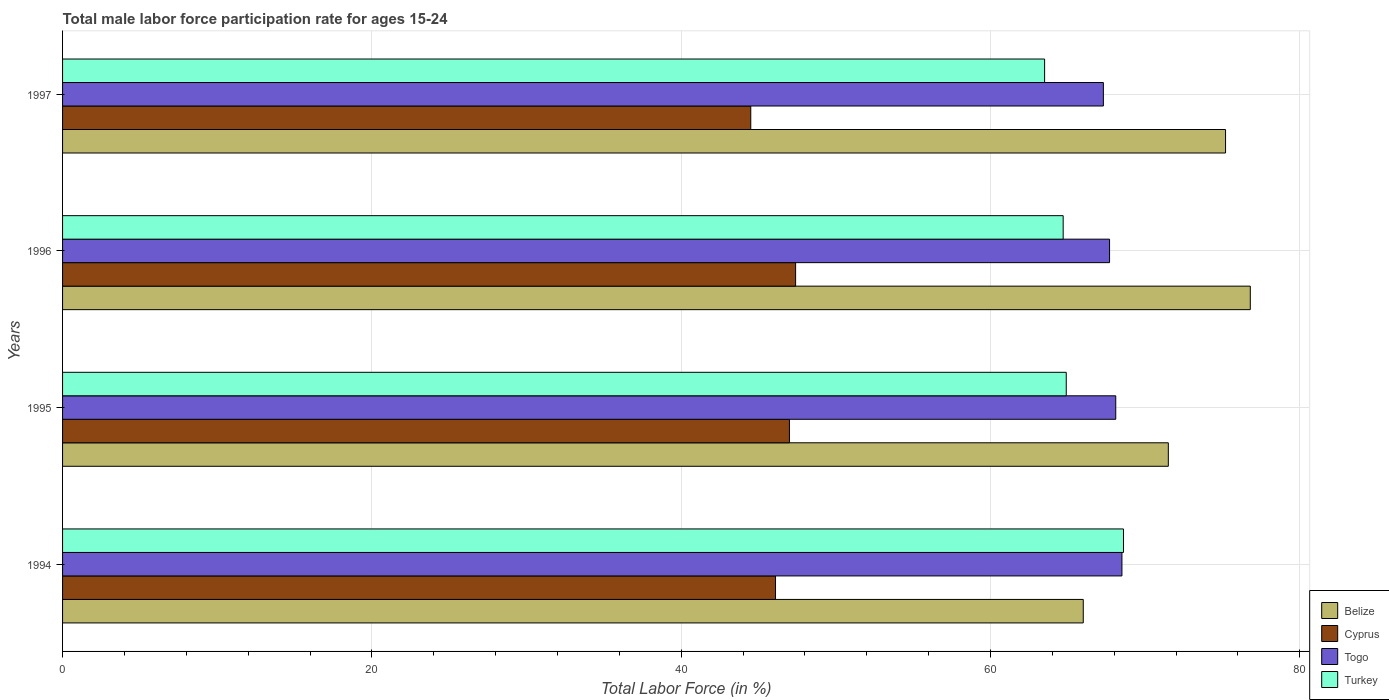How many different coloured bars are there?
Your answer should be compact. 4. How many groups of bars are there?
Keep it short and to the point. 4. How many bars are there on the 3rd tick from the top?
Ensure brevity in your answer.  4. How many bars are there on the 3rd tick from the bottom?
Give a very brief answer. 4. What is the label of the 2nd group of bars from the top?
Ensure brevity in your answer.  1996. In how many cases, is the number of bars for a given year not equal to the number of legend labels?
Make the answer very short. 0. What is the male labor force participation rate in Cyprus in 1997?
Provide a succinct answer. 44.5. Across all years, what is the maximum male labor force participation rate in Togo?
Give a very brief answer. 68.5. In which year was the male labor force participation rate in Cyprus minimum?
Ensure brevity in your answer.  1997. What is the total male labor force participation rate in Cyprus in the graph?
Provide a short and direct response. 185. What is the average male labor force participation rate in Togo per year?
Keep it short and to the point. 67.9. In the year 1996, what is the difference between the male labor force participation rate in Turkey and male labor force participation rate in Togo?
Make the answer very short. -3. What is the ratio of the male labor force participation rate in Turkey in 1994 to that in 1995?
Your answer should be very brief. 1.06. What is the difference between the highest and the second highest male labor force participation rate in Togo?
Provide a succinct answer. 0.4. What is the difference between the highest and the lowest male labor force participation rate in Turkey?
Your response must be concise. 5.1. In how many years, is the male labor force participation rate in Belize greater than the average male labor force participation rate in Belize taken over all years?
Ensure brevity in your answer.  2. Is the sum of the male labor force participation rate in Togo in 1994 and 1996 greater than the maximum male labor force participation rate in Turkey across all years?
Your answer should be very brief. Yes. What does the 2nd bar from the top in 1996 represents?
Keep it short and to the point. Togo. How many bars are there?
Offer a terse response. 16. What is the difference between two consecutive major ticks on the X-axis?
Provide a succinct answer. 20. Does the graph contain any zero values?
Give a very brief answer. No. Does the graph contain grids?
Your response must be concise. Yes. Where does the legend appear in the graph?
Your answer should be very brief. Bottom right. How are the legend labels stacked?
Offer a very short reply. Vertical. What is the title of the graph?
Your answer should be compact. Total male labor force participation rate for ages 15-24. What is the label or title of the X-axis?
Provide a succinct answer. Total Labor Force (in %). What is the label or title of the Y-axis?
Offer a very short reply. Years. What is the Total Labor Force (in %) of Belize in 1994?
Your response must be concise. 66. What is the Total Labor Force (in %) of Cyprus in 1994?
Ensure brevity in your answer.  46.1. What is the Total Labor Force (in %) in Togo in 1994?
Offer a terse response. 68.5. What is the Total Labor Force (in %) of Turkey in 1994?
Offer a terse response. 68.6. What is the Total Labor Force (in %) of Belize in 1995?
Keep it short and to the point. 71.5. What is the Total Labor Force (in %) of Cyprus in 1995?
Ensure brevity in your answer.  47. What is the Total Labor Force (in %) in Togo in 1995?
Your answer should be compact. 68.1. What is the Total Labor Force (in %) in Turkey in 1995?
Offer a very short reply. 64.9. What is the Total Labor Force (in %) in Belize in 1996?
Give a very brief answer. 76.8. What is the Total Labor Force (in %) in Cyprus in 1996?
Make the answer very short. 47.4. What is the Total Labor Force (in %) of Togo in 1996?
Provide a succinct answer. 67.7. What is the Total Labor Force (in %) in Turkey in 1996?
Provide a succinct answer. 64.7. What is the Total Labor Force (in %) of Belize in 1997?
Your response must be concise. 75.2. What is the Total Labor Force (in %) of Cyprus in 1997?
Ensure brevity in your answer.  44.5. What is the Total Labor Force (in %) in Togo in 1997?
Make the answer very short. 67.3. What is the Total Labor Force (in %) of Turkey in 1997?
Your answer should be very brief. 63.5. Across all years, what is the maximum Total Labor Force (in %) of Belize?
Keep it short and to the point. 76.8. Across all years, what is the maximum Total Labor Force (in %) in Cyprus?
Your answer should be compact. 47.4. Across all years, what is the maximum Total Labor Force (in %) of Togo?
Make the answer very short. 68.5. Across all years, what is the maximum Total Labor Force (in %) in Turkey?
Offer a terse response. 68.6. Across all years, what is the minimum Total Labor Force (in %) of Belize?
Ensure brevity in your answer.  66. Across all years, what is the minimum Total Labor Force (in %) of Cyprus?
Provide a short and direct response. 44.5. Across all years, what is the minimum Total Labor Force (in %) in Togo?
Your response must be concise. 67.3. Across all years, what is the minimum Total Labor Force (in %) of Turkey?
Give a very brief answer. 63.5. What is the total Total Labor Force (in %) of Belize in the graph?
Provide a succinct answer. 289.5. What is the total Total Labor Force (in %) in Cyprus in the graph?
Your response must be concise. 185. What is the total Total Labor Force (in %) of Togo in the graph?
Your answer should be very brief. 271.6. What is the total Total Labor Force (in %) of Turkey in the graph?
Provide a short and direct response. 261.7. What is the difference between the Total Labor Force (in %) in Turkey in 1994 and that in 1995?
Keep it short and to the point. 3.7. What is the difference between the Total Labor Force (in %) in Belize in 1994 and that in 1996?
Ensure brevity in your answer.  -10.8. What is the difference between the Total Labor Force (in %) of Cyprus in 1994 and that in 1996?
Provide a succinct answer. -1.3. What is the difference between the Total Labor Force (in %) of Cyprus in 1994 and that in 1997?
Your answer should be very brief. 1.6. What is the difference between the Total Labor Force (in %) in Togo in 1994 and that in 1997?
Make the answer very short. 1.2. What is the difference between the Total Labor Force (in %) of Cyprus in 1995 and that in 1996?
Provide a short and direct response. -0.4. What is the difference between the Total Labor Force (in %) of Turkey in 1995 and that in 1996?
Give a very brief answer. 0.2. What is the difference between the Total Labor Force (in %) in Belize in 1995 and that in 1997?
Ensure brevity in your answer.  -3.7. What is the difference between the Total Labor Force (in %) in Cyprus in 1995 and that in 1997?
Provide a succinct answer. 2.5. What is the difference between the Total Labor Force (in %) of Togo in 1995 and that in 1997?
Make the answer very short. 0.8. What is the difference between the Total Labor Force (in %) in Belize in 1996 and that in 1997?
Your answer should be compact. 1.6. What is the difference between the Total Labor Force (in %) in Belize in 1994 and the Total Labor Force (in %) in Togo in 1995?
Provide a succinct answer. -2.1. What is the difference between the Total Labor Force (in %) in Belize in 1994 and the Total Labor Force (in %) in Turkey in 1995?
Ensure brevity in your answer.  1.1. What is the difference between the Total Labor Force (in %) in Cyprus in 1994 and the Total Labor Force (in %) in Togo in 1995?
Your response must be concise. -22. What is the difference between the Total Labor Force (in %) of Cyprus in 1994 and the Total Labor Force (in %) of Turkey in 1995?
Offer a terse response. -18.8. What is the difference between the Total Labor Force (in %) of Belize in 1994 and the Total Labor Force (in %) of Cyprus in 1996?
Offer a terse response. 18.6. What is the difference between the Total Labor Force (in %) of Belize in 1994 and the Total Labor Force (in %) of Togo in 1996?
Offer a terse response. -1.7. What is the difference between the Total Labor Force (in %) of Belize in 1994 and the Total Labor Force (in %) of Turkey in 1996?
Ensure brevity in your answer.  1.3. What is the difference between the Total Labor Force (in %) of Cyprus in 1994 and the Total Labor Force (in %) of Togo in 1996?
Your answer should be very brief. -21.6. What is the difference between the Total Labor Force (in %) of Cyprus in 1994 and the Total Labor Force (in %) of Turkey in 1996?
Provide a short and direct response. -18.6. What is the difference between the Total Labor Force (in %) in Togo in 1994 and the Total Labor Force (in %) in Turkey in 1996?
Your answer should be compact. 3.8. What is the difference between the Total Labor Force (in %) of Belize in 1994 and the Total Labor Force (in %) of Togo in 1997?
Keep it short and to the point. -1.3. What is the difference between the Total Labor Force (in %) in Belize in 1994 and the Total Labor Force (in %) in Turkey in 1997?
Give a very brief answer. 2.5. What is the difference between the Total Labor Force (in %) of Cyprus in 1994 and the Total Labor Force (in %) of Togo in 1997?
Keep it short and to the point. -21.2. What is the difference between the Total Labor Force (in %) in Cyprus in 1994 and the Total Labor Force (in %) in Turkey in 1997?
Offer a very short reply. -17.4. What is the difference between the Total Labor Force (in %) of Belize in 1995 and the Total Labor Force (in %) of Cyprus in 1996?
Provide a short and direct response. 24.1. What is the difference between the Total Labor Force (in %) in Belize in 1995 and the Total Labor Force (in %) in Togo in 1996?
Ensure brevity in your answer.  3.8. What is the difference between the Total Labor Force (in %) in Cyprus in 1995 and the Total Labor Force (in %) in Togo in 1996?
Offer a very short reply. -20.7. What is the difference between the Total Labor Force (in %) in Cyprus in 1995 and the Total Labor Force (in %) in Turkey in 1996?
Ensure brevity in your answer.  -17.7. What is the difference between the Total Labor Force (in %) in Togo in 1995 and the Total Labor Force (in %) in Turkey in 1996?
Offer a terse response. 3.4. What is the difference between the Total Labor Force (in %) of Belize in 1995 and the Total Labor Force (in %) of Turkey in 1997?
Your answer should be compact. 8. What is the difference between the Total Labor Force (in %) of Cyprus in 1995 and the Total Labor Force (in %) of Togo in 1997?
Provide a short and direct response. -20.3. What is the difference between the Total Labor Force (in %) of Cyprus in 1995 and the Total Labor Force (in %) of Turkey in 1997?
Offer a terse response. -16.5. What is the difference between the Total Labor Force (in %) of Togo in 1995 and the Total Labor Force (in %) of Turkey in 1997?
Make the answer very short. 4.6. What is the difference between the Total Labor Force (in %) in Belize in 1996 and the Total Labor Force (in %) in Cyprus in 1997?
Ensure brevity in your answer.  32.3. What is the difference between the Total Labor Force (in %) of Belize in 1996 and the Total Labor Force (in %) of Togo in 1997?
Offer a very short reply. 9.5. What is the difference between the Total Labor Force (in %) of Belize in 1996 and the Total Labor Force (in %) of Turkey in 1997?
Make the answer very short. 13.3. What is the difference between the Total Labor Force (in %) in Cyprus in 1996 and the Total Labor Force (in %) in Togo in 1997?
Give a very brief answer. -19.9. What is the difference between the Total Labor Force (in %) in Cyprus in 1996 and the Total Labor Force (in %) in Turkey in 1997?
Provide a succinct answer. -16.1. What is the average Total Labor Force (in %) of Belize per year?
Make the answer very short. 72.38. What is the average Total Labor Force (in %) of Cyprus per year?
Provide a short and direct response. 46.25. What is the average Total Labor Force (in %) in Togo per year?
Your response must be concise. 67.9. What is the average Total Labor Force (in %) of Turkey per year?
Provide a short and direct response. 65.42. In the year 1994, what is the difference between the Total Labor Force (in %) in Cyprus and Total Labor Force (in %) in Togo?
Make the answer very short. -22.4. In the year 1994, what is the difference between the Total Labor Force (in %) in Cyprus and Total Labor Force (in %) in Turkey?
Your answer should be compact. -22.5. In the year 1994, what is the difference between the Total Labor Force (in %) of Togo and Total Labor Force (in %) of Turkey?
Provide a short and direct response. -0.1. In the year 1995, what is the difference between the Total Labor Force (in %) of Cyprus and Total Labor Force (in %) of Togo?
Keep it short and to the point. -21.1. In the year 1995, what is the difference between the Total Labor Force (in %) of Cyprus and Total Labor Force (in %) of Turkey?
Keep it short and to the point. -17.9. In the year 1996, what is the difference between the Total Labor Force (in %) in Belize and Total Labor Force (in %) in Cyprus?
Your answer should be very brief. 29.4. In the year 1996, what is the difference between the Total Labor Force (in %) of Cyprus and Total Labor Force (in %) of Togo?
Your answer should be very brief. -20.3. In the year 1996, what is the difference between the Total Labor Force (in %) of Cyprus and Total Labor Force (in %) of Turkey?
Provide a succinct answer. -17.3. In the year 1997, what is the difference between the Total Labor Force (in %) of Belize and Total Labor Force (in %) of Cyprus?
Ensure brevity in your answer.  30.7. In the year 1997, what is the difference between the Total Labor Force (in %) in Belize and Total Labor Force (in %) in Togo?
Offer a terse response. 7.9. In the year 1997, what is the difference between the Total Labor Force (in %) of Cyprus and Total Labor Force (in %) of Togo?
Offer a very short reply. -22.8. What is the ratio of the Total Labor Force (in %) of Belize in 1994 to that in 1995?
Provide a succinct answer. 0.92. What is the ratio of the Total Labor Force (in %) in Cyprus in 1994 to that in 1995?
Provide a succinct answer. 0.98. What is the ratio of the Total Labor Force (in %) of Togo in 1994 to that in 1995?
Offer a terse response. 1.01. What is the ratio of the Total Labor Force (in %) in Turkey in 1994 to that in 1995?
Your answer should be compact. 1.06. What is the ratio of the Total Labor Force (in %) of Belize in 1994 to that in 1996?
Keep it short and to the point. 0.86. What is the ratio of the Total Labor Force (in %) in Cyprus in 1994 to that in 1996?
Offer a very short reply. 0.97. What is the ratio of the Total Labor Force (in %) of Togo in 1994 to that in 1996?
Make the answer very short. 1.01. What is the ratio of the Total Labor Force (in %) of Turkey in 1994 to that in 1996?
Your answer should be very brief. 1.06. What is the ratio of the Total Labor Force (in %) of Belize in 1994 to that in 1997?
Offer a terse response. 0.88. What is the ratio of the Total Labor Force (in %) in Cyprus in 1994 to that in 1997?
Give a very brief answer. 1.04. What is the ratio of the Total Labor Force (in %) of Togo in 1994 to that in 1997?
Your answer should be very brief. 1.02. What is the ratio of the Total Labor Force (in %) of Turkey in 1994 to that in 1997?
Your answer should be very brief. 1.08. What is the ratio of the Total Labor Force (in %) in Belize in 1995 to that in 1996?
Make the answer very short. 0.93. What is the ratio of the Total Labor Force (in %) in Cyprus in 1995 to that in 1996?
Give a very brief answer. 0.99. What is the ratio of the Total Labor Force (in %) in Togo in 1995 to that in 1996?
Make the answer very short. 1.01. What is the ratio of the Total Labor Force (in %) in Turkey in 1995 to that in 1996?
Provide a short and direct response. 1. What is the ratio of the Total Labor Force (in %) in Belize in 1995 to that in 1997?
Make the answer very short. 0.95. What is the ratio of the Total Labor Force (in %) of Cyprus in 1995 to that in 1997?
Keep it short and to the point. 1.06. What is the ratio of the Total Labor Force (in %) of Togo in 1995 to that in 1997?
Provide a short and direct response. 1.01. What is the ratio of the Total Labor Force (in %) in Belize in 1996 to that in 1997?
Provide a short and direct response. 1.02. What is the ratio of the Total Labor Force (in %) of Cyprus in 1996 to that in 1997?
Offer a terse response. 1.07. What is the ratio of the Total Labor Force (in %) in Togo in 1996 to that in 1997?
Your response must be concise. 1.01. What is the ratio of the Total Labor Force (in %) of Turkey in 1996 to that in 1997?
Your response must be concise. 1.02. What is the difference between the highest and the second highest Total Labor Force (in %) of Togo?
Your response must be concise. 0.4. What is the difference between the highest and the second highest Total Labor Force (in %) of Turkey?
Provide a short and direct response. 3.7. What is the difference between the highest and the lowest Total Labor Force (in %) in Belize?
Provide a succinct answer. 10.8. 